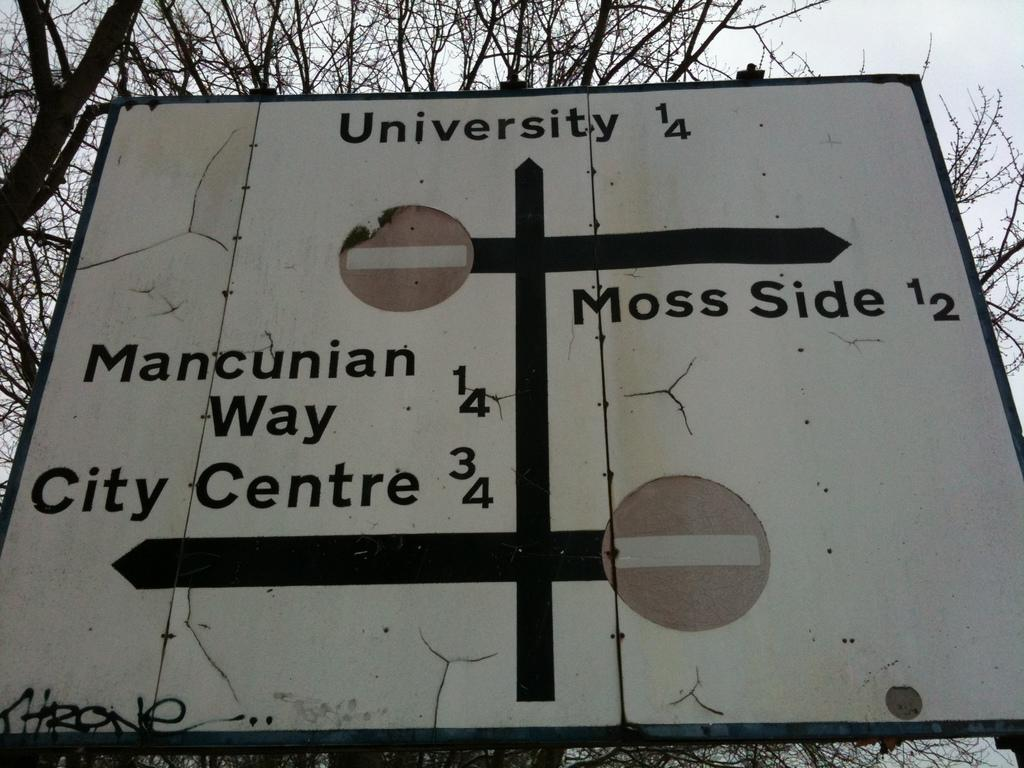What type of natural elements can be seen in the image? There are trees in the image. What man-made object is present in the image? There is a board with text in the image. What information is provided on the board? There are directions on the board. What is visible in the background of the image? The sky is visible in the image. What type of steel structure can be seen in the image? There is no steel structure present in the image. What kind of test is being conducted in the image? There is no test being conducted in the image. 